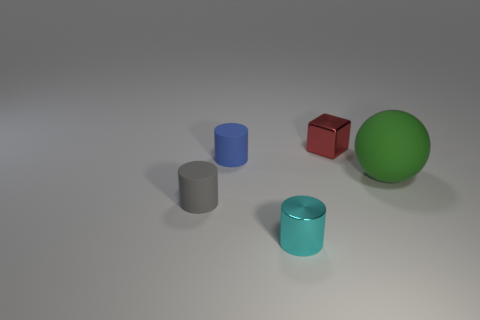Is there anything else that has the same size as the green matte object?
Your answer should be very brief. No. There is a small thing that is made of the same material as the tiny red block; what is its color?
Ensure brevity in your answer.  Cyan. What is the shape of the matte thing to the right of the matte thing behind the rubber thing on the right side of the red thing?
Keep it short and to the point. Sphere. What is the size of the cyan cylinder?
Offer a terse response. Small. What shape is the big green object that is made of the same material as the tiny gray thing?
Ensure brevity in your answer.  Sphere. Are there fewer tiny gray rubber cylinders that are behind the blue thing than cyan objects?
Provide a short and direct response. Yes. There is a shiny object that is behind the tiny cyan metal thing; what is its color?
Provide a succinct answer. Red. Are there any other small objects that have the same shape as the cyan thing?
Provide a succinct answer. Yes. How many green things are the same shape as the blue rubber thing?
Offer a terse response. 0. Is the number of tiny matte objects less than the number of things?
Offer a terse response. Yes. 